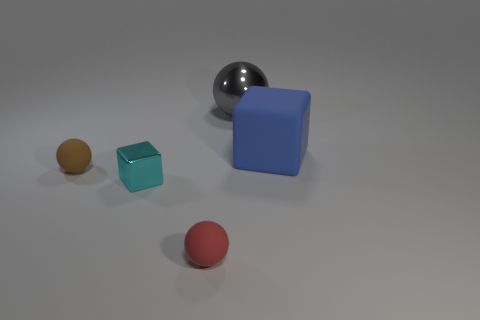There is a metal thing that is in front of the matte object behind the brown matte sphere; what number of big blue rubber blocks are on the left side of it?
Your answer should be compact. 0. Is the number of tiny red matte spheres that are right of the blue rubber block less than the number of big cyan shiny cylinders?
Provide a short and direct response. No. Are there any other things that are the same shape as the blue thing?
Your answer should be very brief. Yes. There is a metallic thing that is behind the brown thing; what shape is it?
Your response must be concise. Sphere. What shape is the large object to the right of the gray metallic ball that is to the right of the shiny object that is in front of the large gray shiny thing?
Make the answer very short. Cube. How many objects are blue cylinders or red rubber objects?
Give a very brief answer. 1. There is a matte thing in front of the small cyan cube; is its shape the same as the big thing on the right side of the large gray metal ball?
Offer a terse response. No. How many balls are both behind the brown matte thing and in front of the cyan metal block?
Your answer should be very brief. 0. How many other objects are the same size as the cyan shiny thing?
Your answer should be very brief. 2. What is the material of the thing that is both right of the tiny red matte ball and to the left of the large blue block?
Give a very brief answer. Metal. 